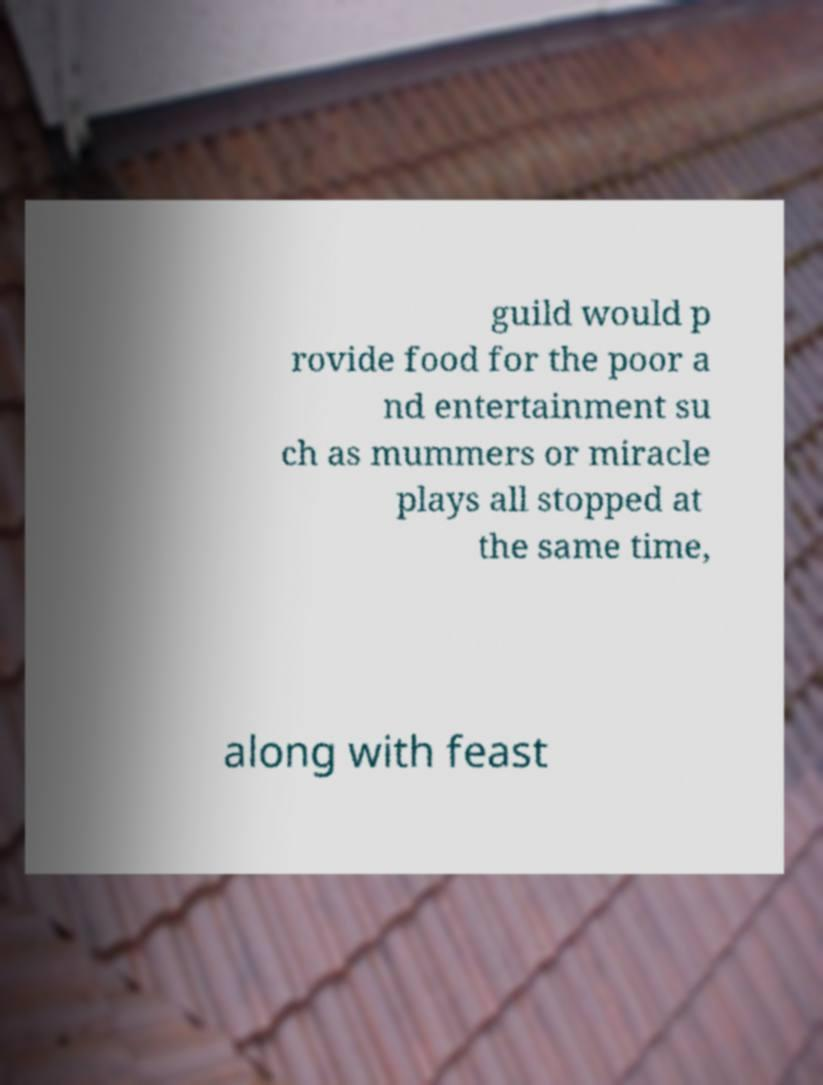Please identify and transcribe the text found in this image. guild would p rovide food for the poor a nd entertainment su ch as mummers or miracle plays all stopped at the same time, along with feast 